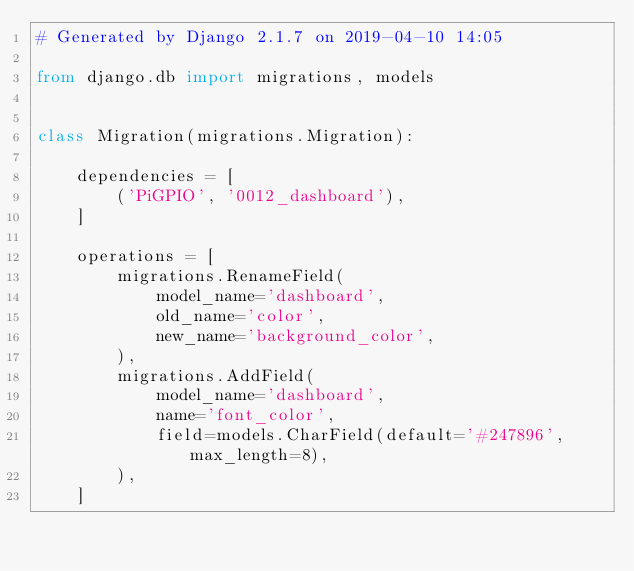<code> <loc_0><loc_0><loc_500><loc_500><_Python_># Generated by Django 2.1.7 on 2019-04-10 14:05

from django.db import migrations, models


class Migration(migrations.Migration):

    dependencies = [
        ('PiGPIO', '0012_dashboard'),
    ]

    operations = [
        migrations.RenameField(
            model_name='dashboard',
            old_name='color',
            new_name='background_color',
        ),
        migrations.AddField(
            model_name='dashboard',
            name='font_color',
            field=models.CharField(default='#247896', max_length=8),
        ),
    ]
</code> 